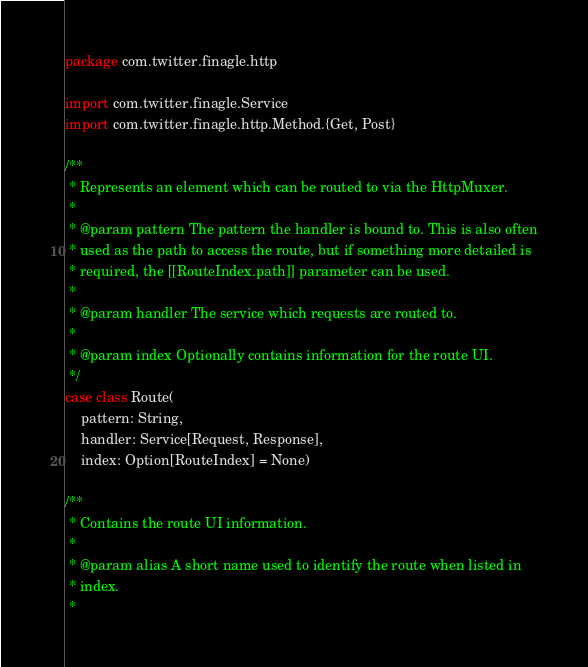Convert code to text. <code><loc_0><loc_0><loc_500><loc_500><_Scala_>package com.twitter.finagle.http

import com.twitter.finagle.Service
import com.twitter.finagle.http.Method.{Get, Post}

/**
 * Represents an element which can be routed to via the HttpMuxer.
 *
 * @param pattern The pattern the handler is bound to. This is also often
 * used as the path to access the route, but if something more detailed is
 * required, the [[RouteIndex.path]] parameter can be used.
 *
 * @param handler The service which requests are routed to.
 *
 * @param index Optionally contains information for the route UI.
 */
case class Route(
    pattern: String,
    handler: Service[Request, Response],
    index: Option[RouteIndex] = None)

/**
 * Contains the route UI information.
 *
 * @param alias A short name used to identify the route when listed in
 * index.
 *</code> 